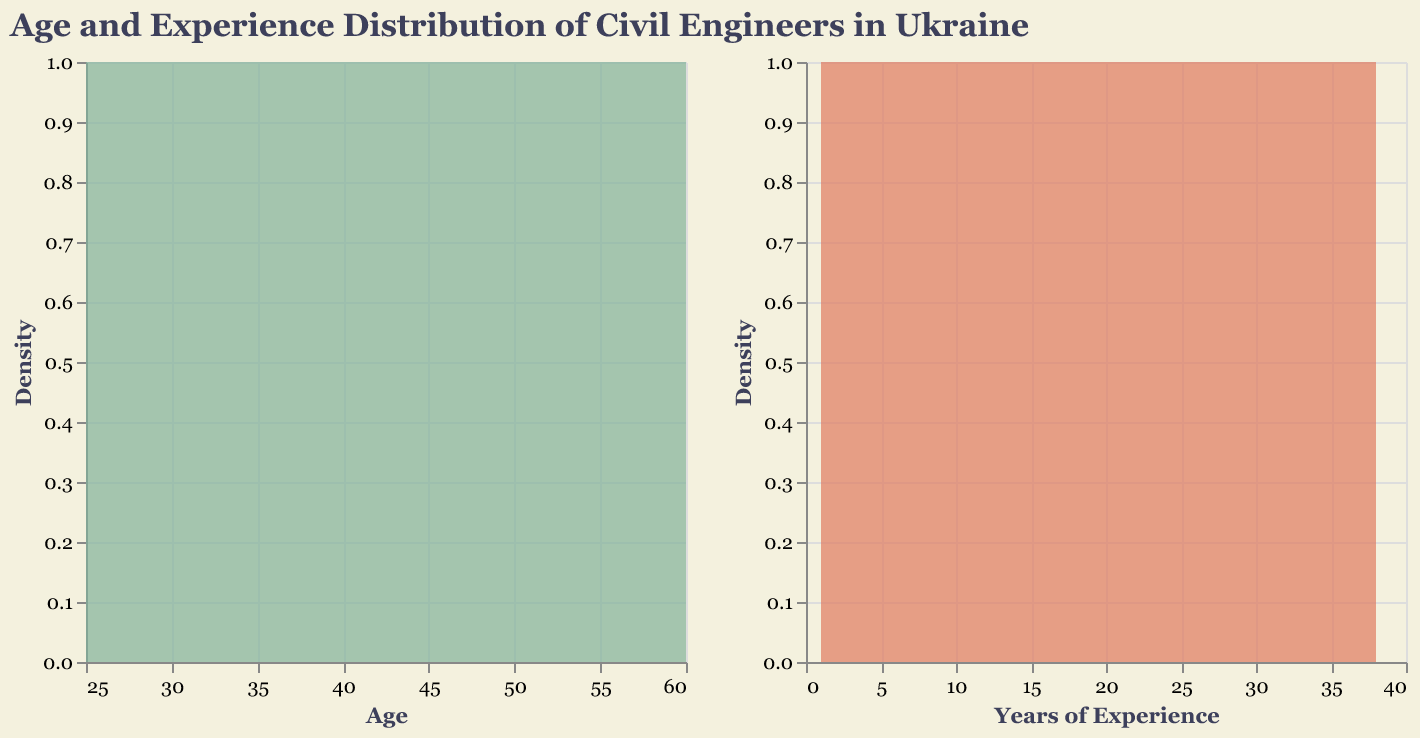Which age group has the highest density of civil engineers? According to the density plot, the age group with the highest density of civil engineers is around 29 years old.
Answer: 29 years old What can you say about the relationship between age and years of experience? From the plots, it seems that age and years of experience are directly correlated, where older engineers have more years of experience.
Answer: Direct correlation How does the density curve change as the age increases from 25 to 60? The density curve starts high and then decreases gradually, indicating that civil engineers tend to be younger; fewer are much older in this dataset.
Answer: Decreases gradually Are there more civil engineers in the younger age groups or the older age groups? By observing the density plot, it is clear that there are more civil engineers in the younger age groups (25-35) compared to older age groups.
Answer: Younger age groups What is the color used for representing age distribution? The color used for representing age distribution in the density plot is greenish hue.
Answer: Greenish hue How does the density plot of years of experience compare to the age distribution? Both density plots show similar trends, indicating a high density in the initial years (1-10 years of experience and ages 25-35) that gradually decreases as both age and experience increase.
Answer: Similar trend, both decrease gradually What can you infer about the number of civil engineers with over 20 years of experience? The density plot shows a marked decrease for civil engineers with over 20 years of experience, indicating that there are fewer civil engineers in this category.
Answer: Fewer civil engineers What age marks the transition from a high to a lower density of civil engineers? The transition from high to lower density for civil engineers occurs around the age of 30.
Answer: Around 30 Does any specific age or experience group dominate the distribution in terms of frequency? Yes, the age group around 29 and the experience group around 5 years dominate the distribution with the highest frequency.
Answer: Age 29 and 5 years experience What general trend can be observed about the ages and years of experience collectively? The general trend observed is that younger civil engineers tend to have fewer years of experience while older civil engineers have more years of experience, both showing a downward trend in density as age and experience increase.
Answer: Downward trend in density as age and experience increase 